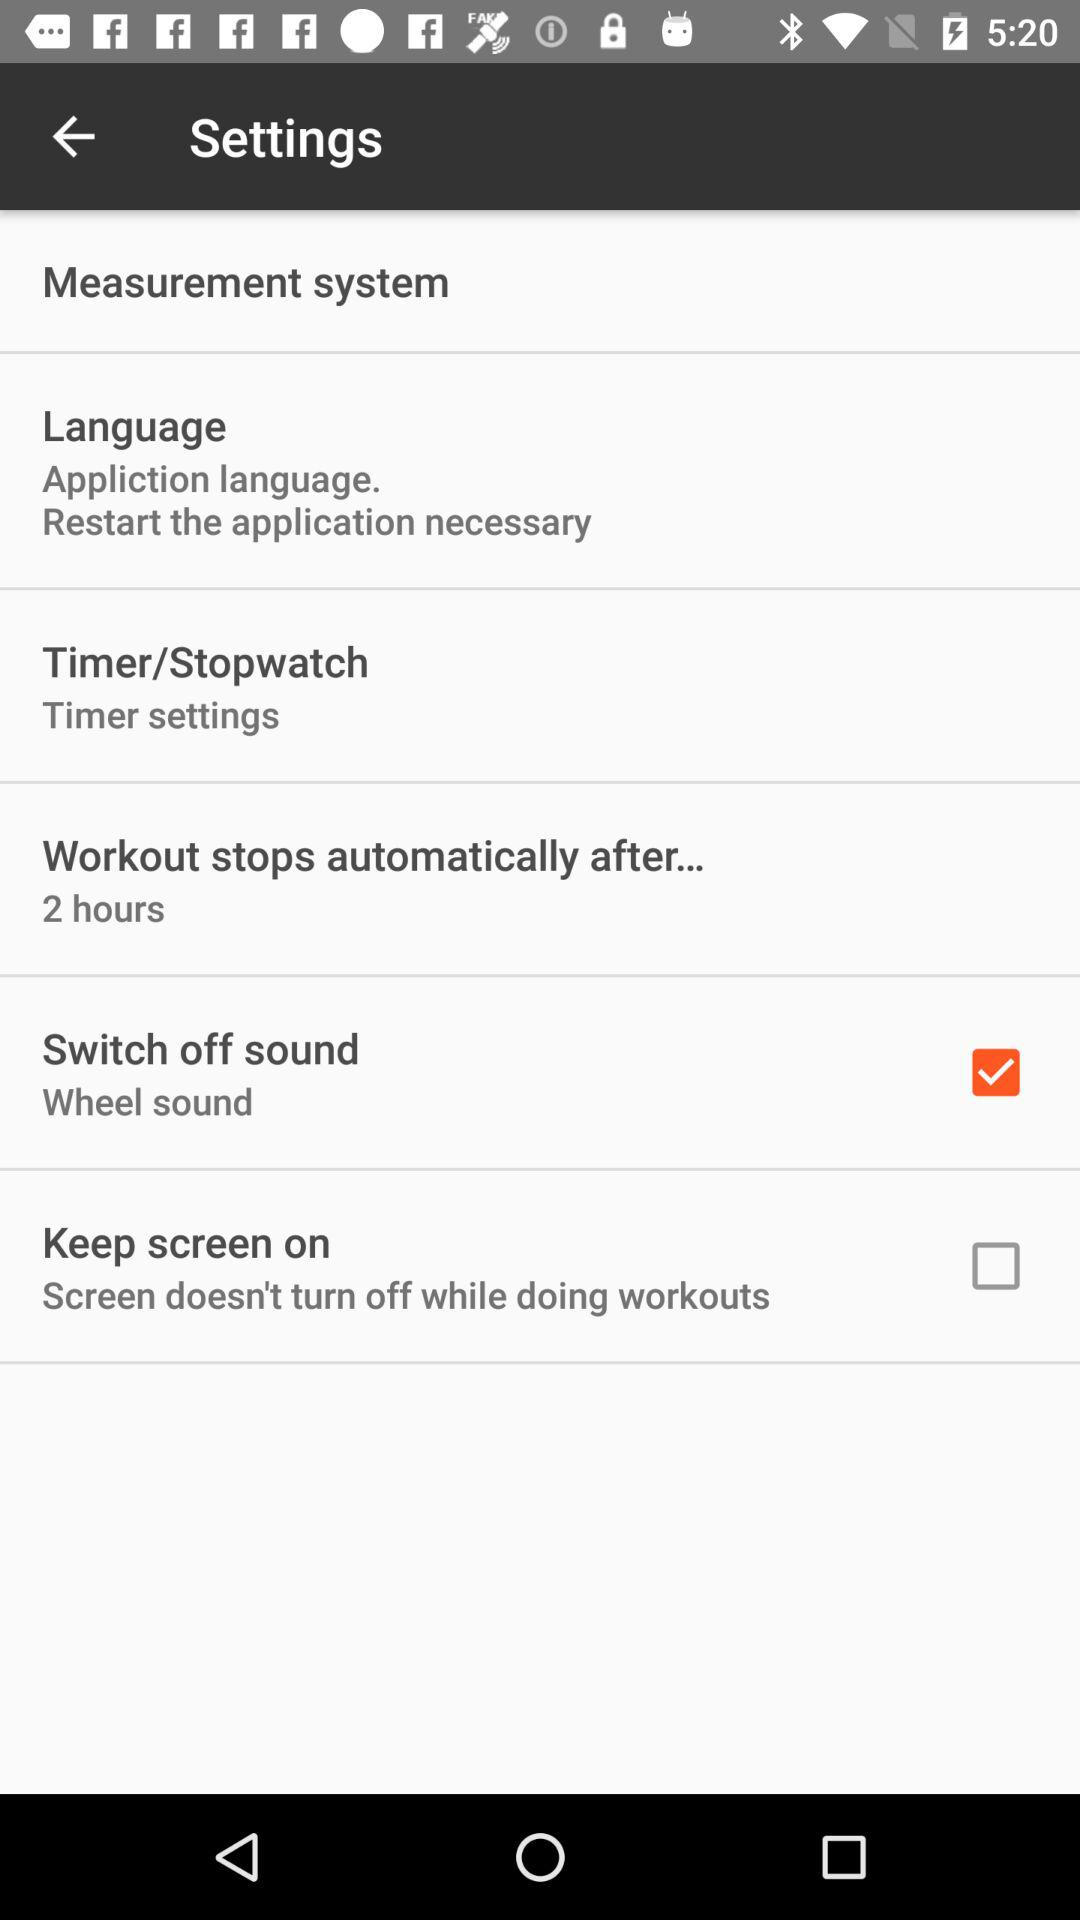Which settings are checked? The checked setting is "Switch off sound". 